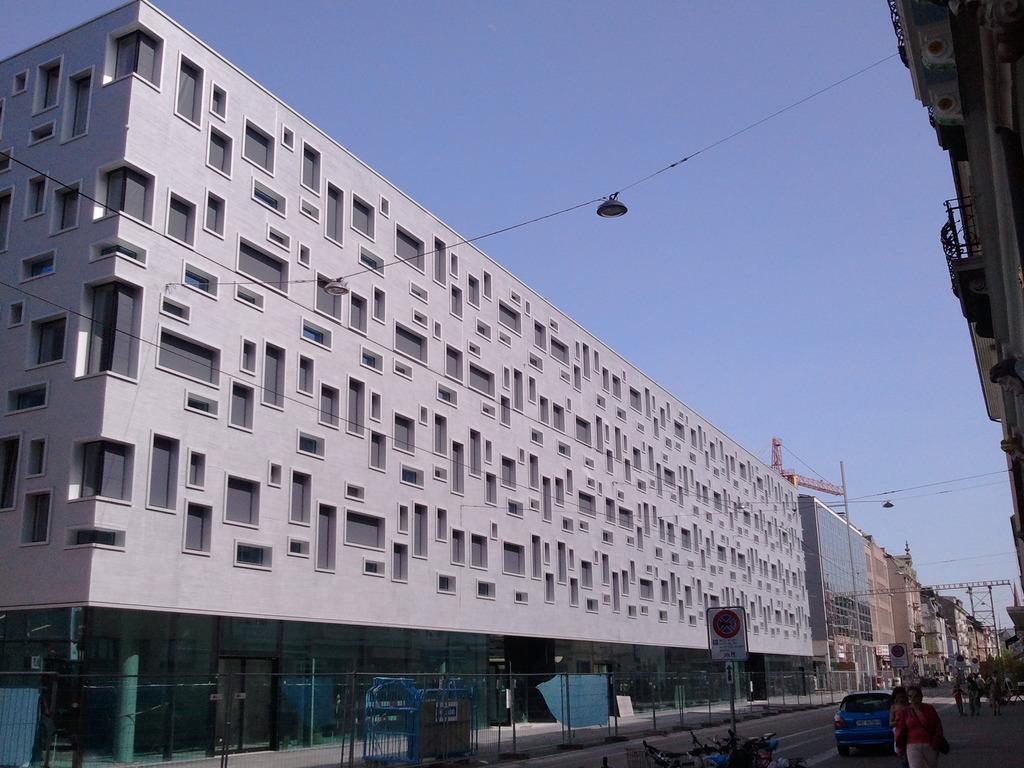How would you summarize this image in a sentence or two? In this image there are vehicles on the road. Left side there is a fence on the pavement. Bottom of the image there is a board attached to the pole. Right bottom few people are walking on the pavement. Few lights are attached to the wires. Background there are buildings. Top of the image there is sky. 